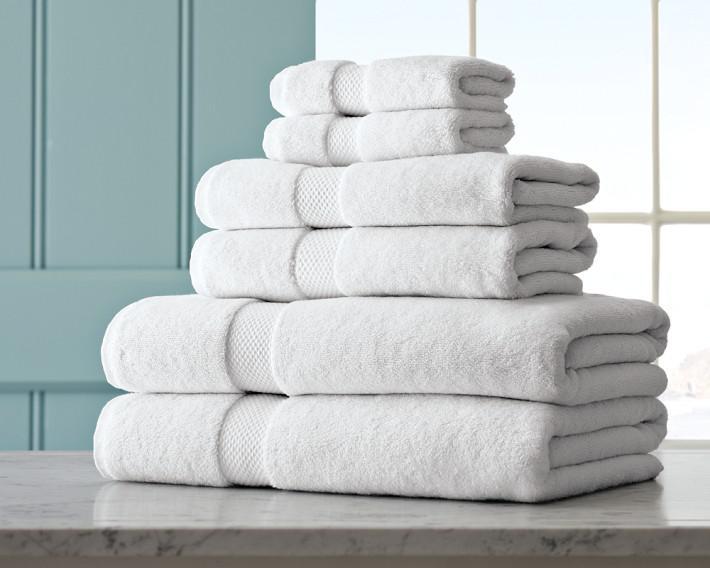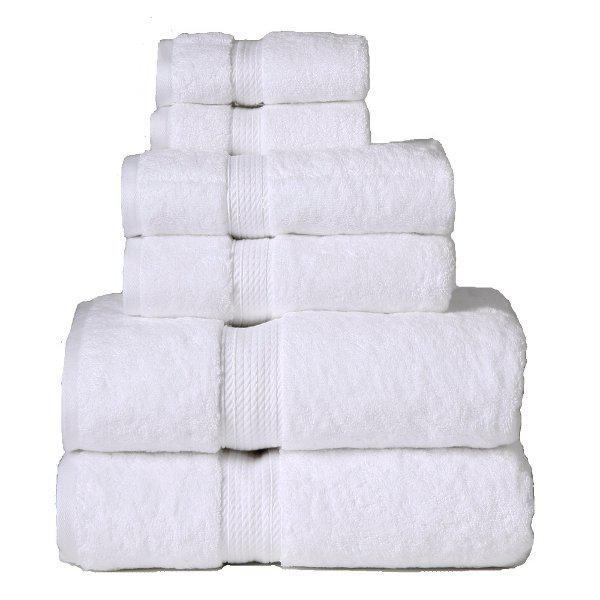The first image is the image on the left, the second image is the image on the right. For the images shown, is this caption "A towel pile includes white towels with contrast stripe trim." true? Answer yes or no. No. 